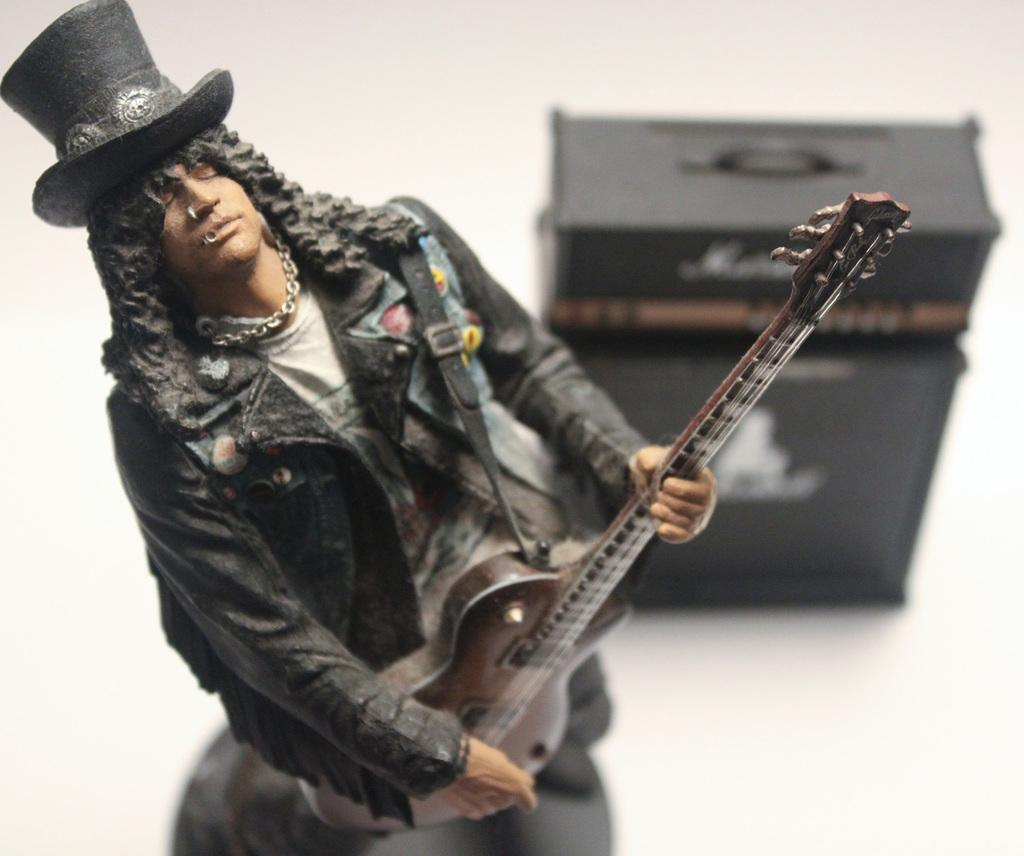What is the main subject of the image? There is a statue of a man in the image. How is the statue positioned in the image? The statue is standing. What is the statue holding in its hand? The statue is holding a guitar in its hand. What type of eggnog is being served at the event in the image? There is no event or eggnog present in the image; it features a statue of a man holding a guitar. 